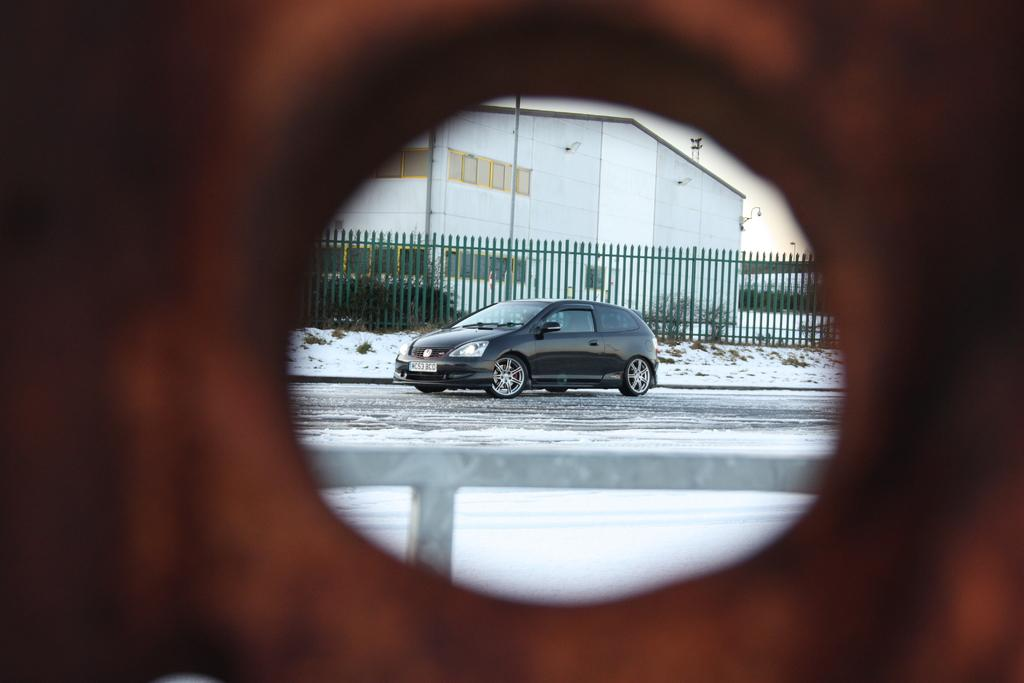What is the main subject of the image? There is a car on the road in the image. What can be seen in the background of the image? There is a railing, trees with green color, a building, and the sky visible in the background of the image. What is the color of the sky in the image? The sky is visible in the background of the image, and it appears to be white in color. What is the car's opinion about the cause of fear in the image? The image does not depict any fear or opinions, and the car is an inanimate object, so it cannot have an opinion. 